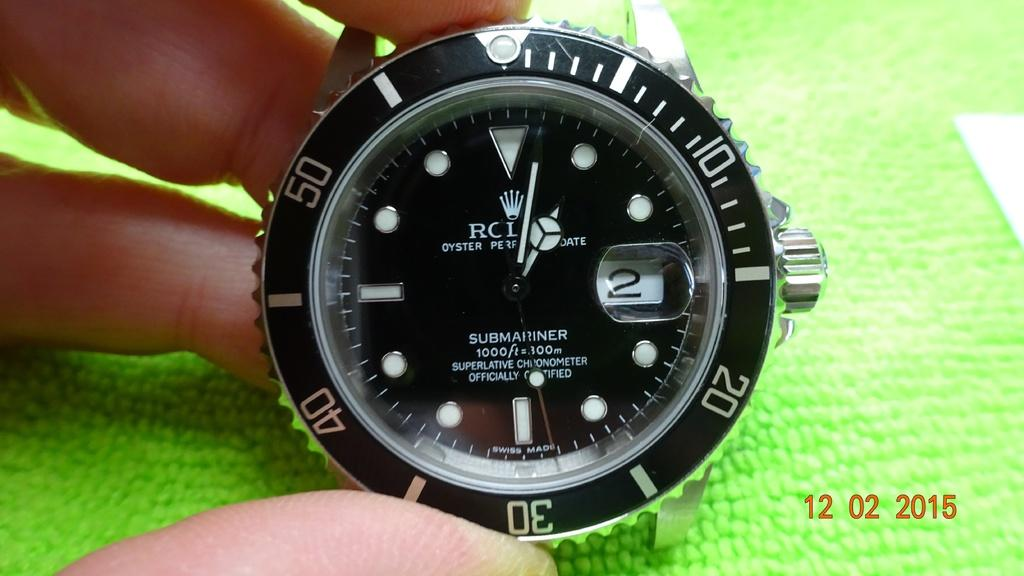<image>
Share a concise interpretation of the image provided. A Swiss-made watch face shows the date to be the second of the month. 